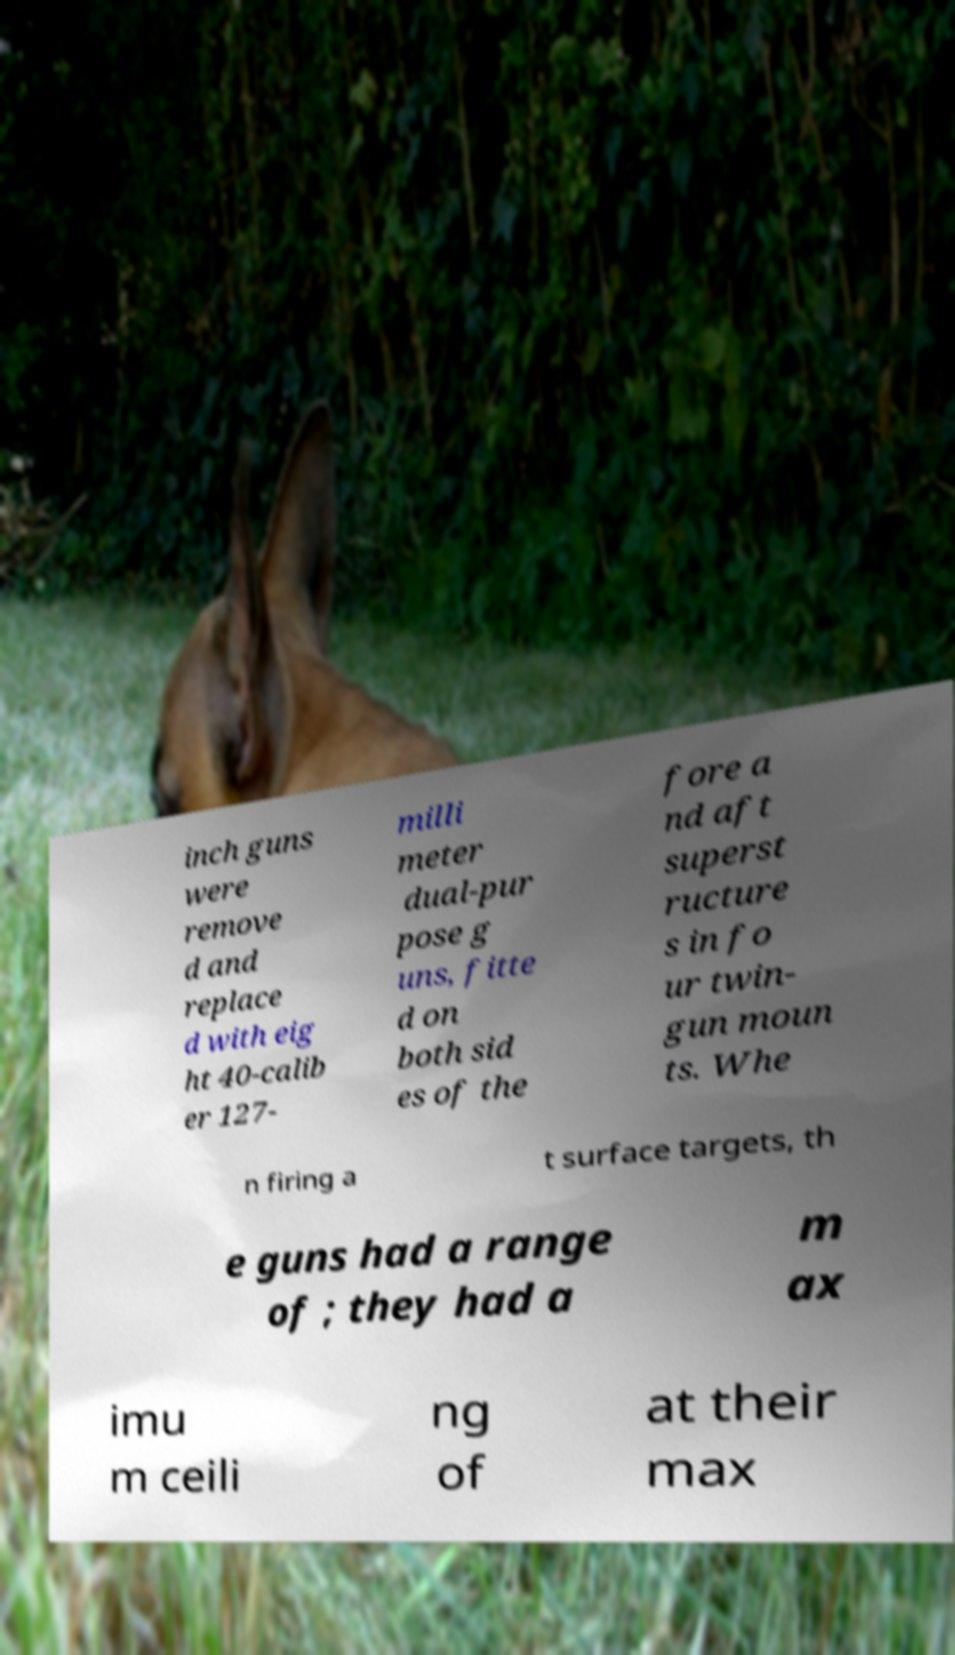Could you assist in decoding the text presented in this image and type it out clearly? inch guns were remove d and replace d with eig ht 40-calib er 127- milli meter dual-pur pose g uns, fitte d on both sid es of the fore a nd aft superst ructure s in fo ur twin- gun moun ts. Whe n firing a t surface targets, th e guns had a range of ; they had a m ax imu m ceili ng of at their max 